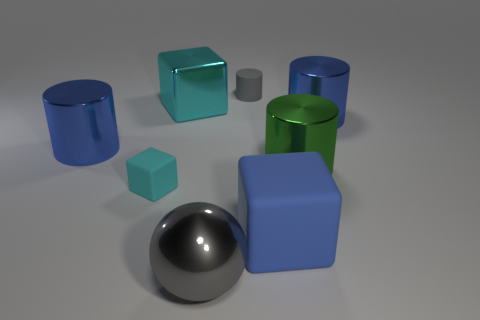The ball that is the same color as the tiny rubber cylinder is what size?
Provide a short and direct response. Large. What number of cyan objects are metallic cubes or rubber cylinders?
Ensure brevity in your answer.  1. Are there any large shiny blocks of the same color as the tiny matte block?
Ensure brevity in your answer.  Yes. The gray object that is the same material as the large green object is what size?
Offer a very short reply. Large. What number of cylinders are green things or gray things?
Make the answer very short. 2. Are there more small blue blocks than cylinders?
Give a very brief answer. No. How many gray rubber objects have the same size as the cyan rubber thing?
Your answer should be compact. 1. What shape is the big thing that is the same color as the rubber cylinder?
Give a very brief answer. Sphere. How many objects are either large blocks on the left side of the large gray ball or rubber blocks?
Your answer should be compact. 3. Are there fewer gray shiny objects than tiny red rubber cylinders?
Offer a terse response. No. 